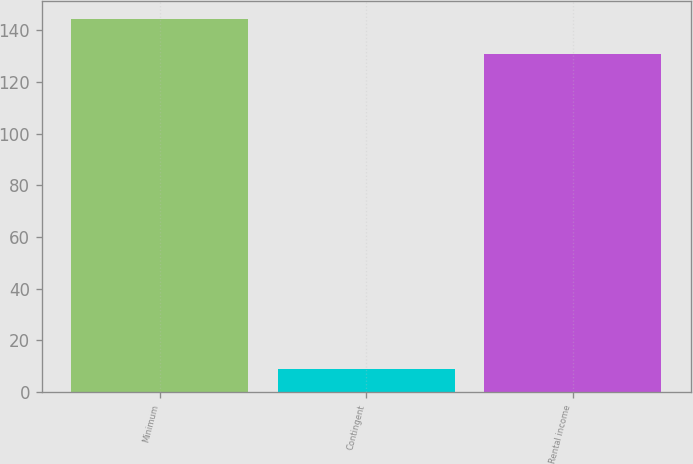Convert chart. <chart><loc_0><loc_0><loc_500><loc_500><bar_chart><fcel>Minimum<fcel>Contingent<fcel>Rental income<nl><fcel>144.3<fcel>9<fcel>131<nl></chart> 